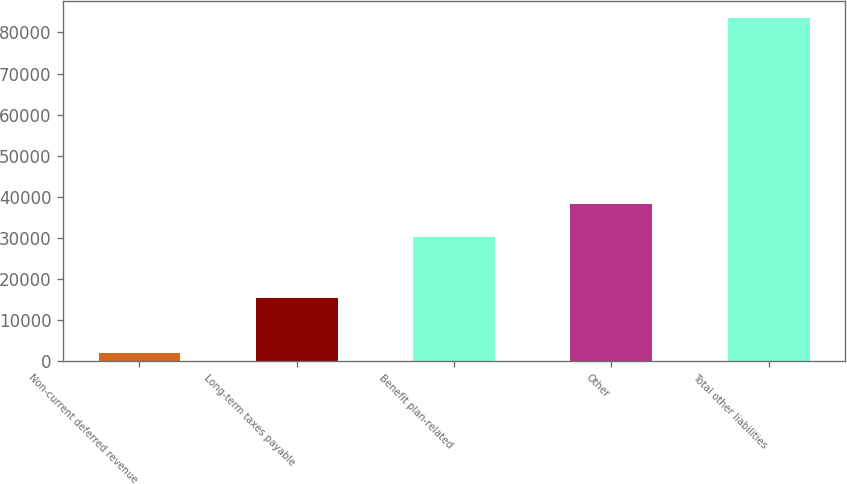<chart> <loc_0><loc_0><loc_500><loc_500><bar_chart><fcel>Non-current deferred revenue<fcel>Long-term taxes payable<fcel>Benefit plan-related<fcel>Other<fcel>Total other liabilities<nl><fcel>1913<fcel>15386<fcel>30098<fcel>38253.9<fcel>83472<nl></chart> 